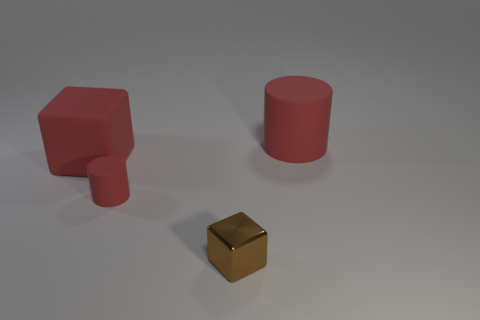Subtract all brown blocks. How many blocks are left? 1 Subtract all green cubes. Subtract all purple balls. How many cubes are left? 2 Subtract all yellow spheres. How many brown blocks are left? 1 Subtract all gray metal things. Subtract all cubes. How many objects are left? 2 Add 2 tiny metal things. How many tiny metal things are left? 3 Add 1 small objects. How many small objects exist? 3 Add 3 small metallic balls. How many objects exist? 7 Subtract 0 blue balls. How many objects are left? 4 Subtract 2 cylinders. How many cylinders are left? 0 